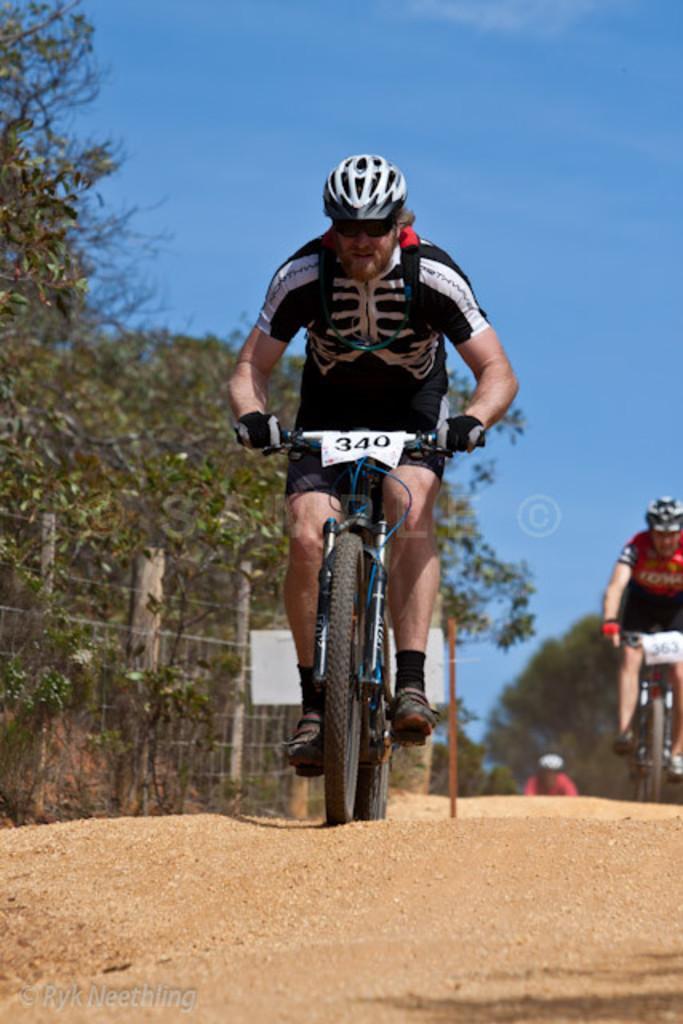Describe this image in one or two sentences. In this image we can see there are two people are bicycling on the road. On the left side of the image there are some trees. In the background there is a sky. 